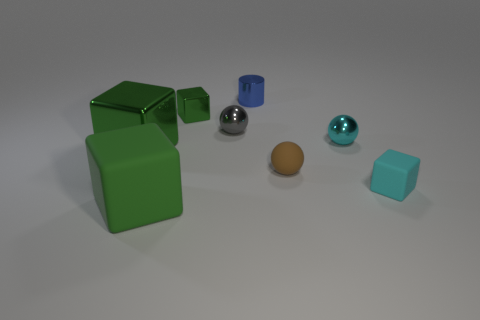How many green cubes must be subtracted to get 1 green cubes? 2 Subtract all purple cylinders. How many green cubes are left? 3 Add 1 tiny cyan blocks. How many objects exist? 9 Subtract all cylinders. How many objects are left? 7 Subtract 0 gray cubes. How many objects are left? 8 Subtract all large green matte cubes. Subtract all big metal blocks. How many objects are left? 6 Add 4 big green rubber things. How many big green rubber things are left? 5 Add 6 big green matte cubes. How many big green matte cubes exist? 7 